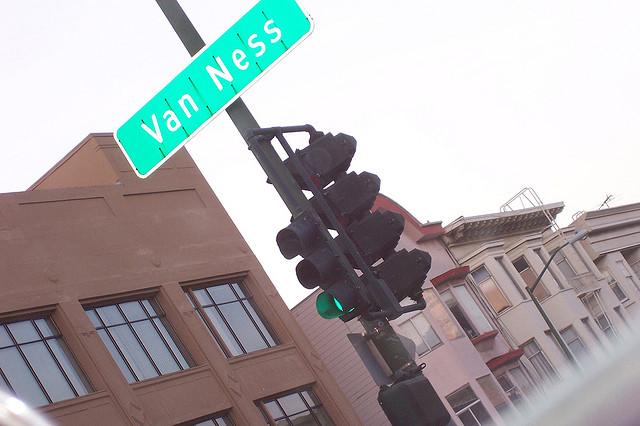Is it snowing out?
Be succinct. No. What does the bottom sign say?
Be succinct. Van ness. Is the green light on?
Quick response, please. Yes. Where is the photo?
Keep it brief. Van ness. Can you ride a bike on the sidewalk?
Short answer required. Yes. What street is this?
Be succinct. Van ness. 